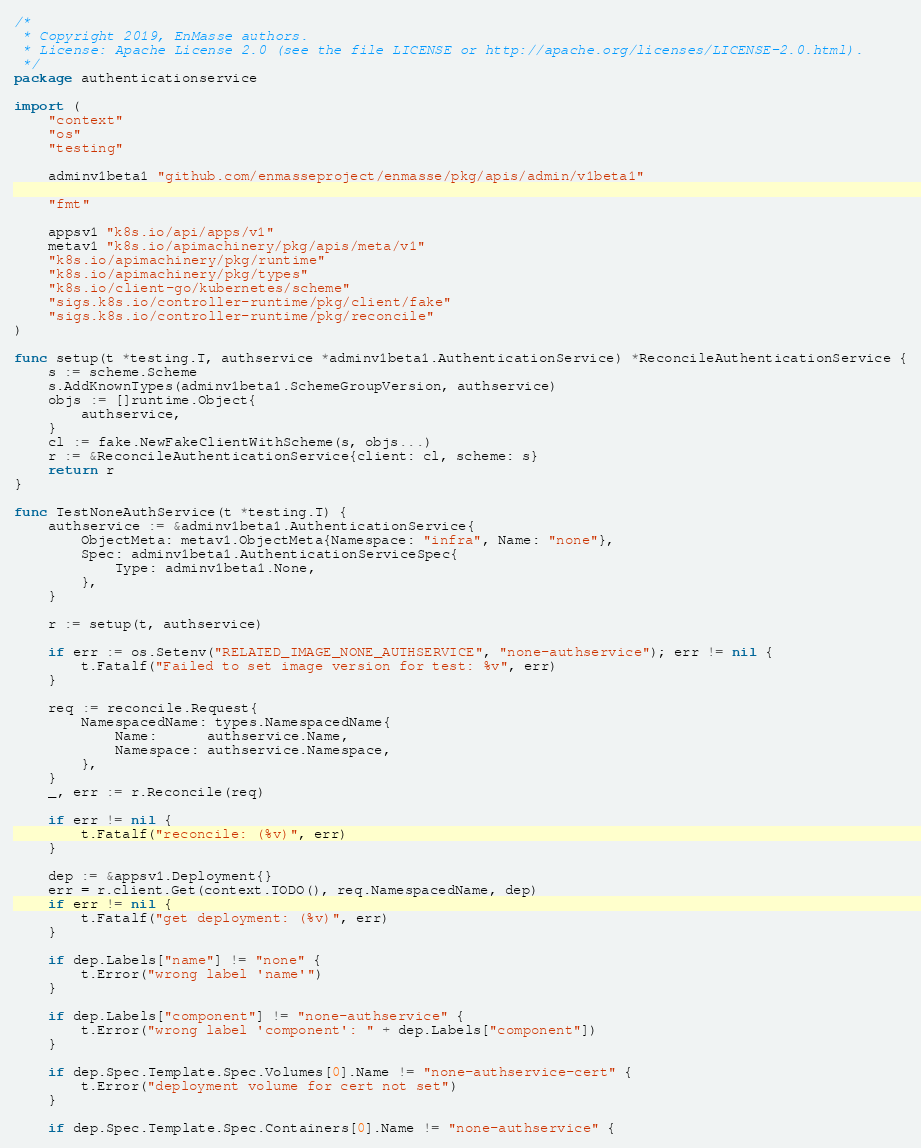Convert code to text. <code><loc_0><loc_0><loc_500><loc_500><_Go_>/*
 * Copyright 2019, EnMasse authors.
 * License: Apache License 2.0 (see the file LICENSE or http://apache.org/licenses/LICENSE-2.0.html).
 */
package authenticationservice

import (
	"context"
	"os"
	"testing"

	adminv1beta1 "github.com/enmasseproject/enmasse/pkg/apis/admin/v1beta1"

	"fmt"

	appsv1 "k8s.io/api/apps/v1"
	metav1 "k8s.io/apimachinery/pkg/apis/meta/v1"
	"k8s.io/apimachinery/pkg/runtime"
	"k8s.io/apimachinery/pkg/types"
	"k8s.io/client-go/kubernetes/scheme"
	"sigs.k8s.io/controller-runtime/pkg/client/fake"
	"sigs.k8s.io/controller-runtime/pkg/reconcile"
)

func setup(t *testing.T, authservice *adminv1beta1.AuthenticationService) *ReconcileAuthenticationService {
	s := scheme.Scheme
	s.AddKnownTypes(adminv1beta1.SchemeGroupVersion, authservice)
	objs := []runtime.Object{
		authservice,
	}
	cl := fake.NewFakeClientWithScheme(s, objs...)
	r := &ReconcileAuthenticationService{client: cl, scheme: s}
	return r
}

func TestNoneAuthService(t *testing.T) {
	authservice := &adminv1beta1.AuthenticationService{
		ObjectMeta: metav1.ObjectMeta{Namespace: "infra", Name: "none"},
		Spec: adminv1beta1.AuthenticationServiceSpec{
			Type: adminv1beta1.None,
		},
	}

	r := setup(t, authservice)

	if err := os.Setenv("RELATED_IMAGE_NONE_AUTHSERVICE", "none-authservice"); err != nil {
		t.Fatalf("Failed to set image version for test: %v", err)
	}

	req := reconcile.Request{
		NamespacedName: types.NamespacedName{
			Name:      authservice.Name,
			Namespace: authservice.Namespace,
		},
	}
	_, err := r.Reconcile(req)

	if err != nil {
		t.Fatalf("reconcile: (%v)", err)
	}

	dep := &appsv1.Deployment{}
	err = r.client.Get(context.TODO(), req.NamespacedName, dep)
	if err != nil {
		t.Fatalf("get deployment: (%v)", err)
	}

	if dep.Labels["name"] != "none" {
		t.Error("wrong label 'name'")
	}

	if dep.Labels["component"] != "none-authservice" {
		t.Error("wrong label 'component': " + dep.Labels["component"])
	}

	if dep.Spec.Template.Spec.Volumes[0].Name != "none-authservice-cert" {
		t.Error("deployment volume for cert not set")
	}

	if dep.Spec.Template.Spec.Containers[0].Name != "none-authservice" {</code> 